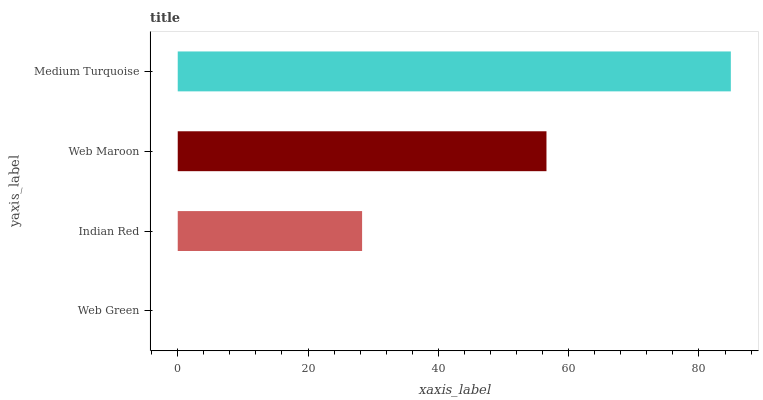Is Web Green the minimum?
Answer yes or no. Yes. Is Medium Turquoise the maximum?
Answer yes or no. Yes. Is Indian Red the minimum?
Answer yes or no. No. Is Indian Red the maximum?
Answer yes or no. No. Is Indian Red greater than Web Green?
Answer yes or no. Yes. Is Web Green less than Indian Red?
Answer yes or no. Yes. Is Web Green greater than Indian Red?
Answer yes or no. No. Is Indian Red less than Web Green?
Answer yes or no. No. Is Web Maroon the high median?
Answer yes or no. Yes. Is Indian Red the low median?
Answer yes or no. Yes. Is Indian Red the high median?
Answer yes or no. No. Is Web Maroon the low median?
Answer yes or no. No. 